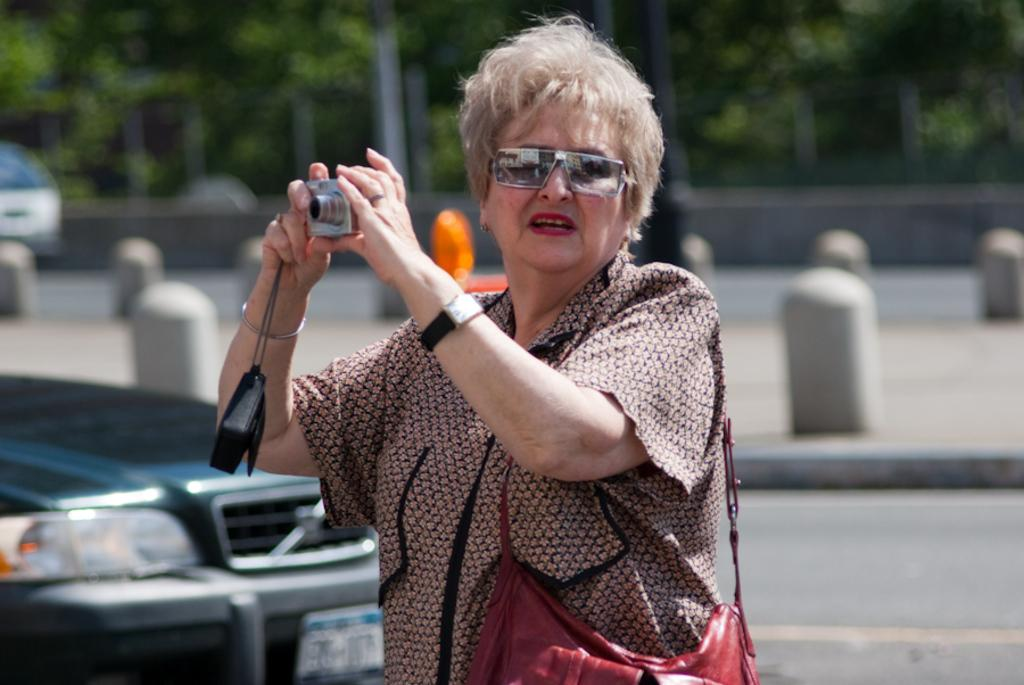Who is the main subject in the image? There is a lady in the center of the image. What is the lady holding in her hands? The lady is holding a camera in her hands. What can be seen in the background of the image? There are vehicles, trees, and poles in the background of the image. What type of riddle is the lady trying to solve in the image? There is no riddle present in the image; the lady is holding a camera. Can you tell me how many kitties are sitting on the lady's lap in the image? There are no kitties present in the image; the lady is holding a camera. 